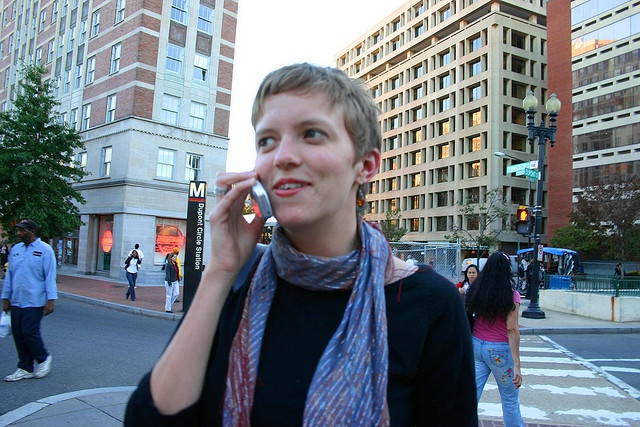Describe the objects in this image and their specific colors. I can see people in lavender, black, darkgray, and gray tones, people in lavender, black, blue, and gray tones, people in lavender, black, lightblue, blue, and gray tones, people in lavender, navy, gray, black, and lightblue tones, and people in lavender, lightblue, black, and navy tones in this image. 